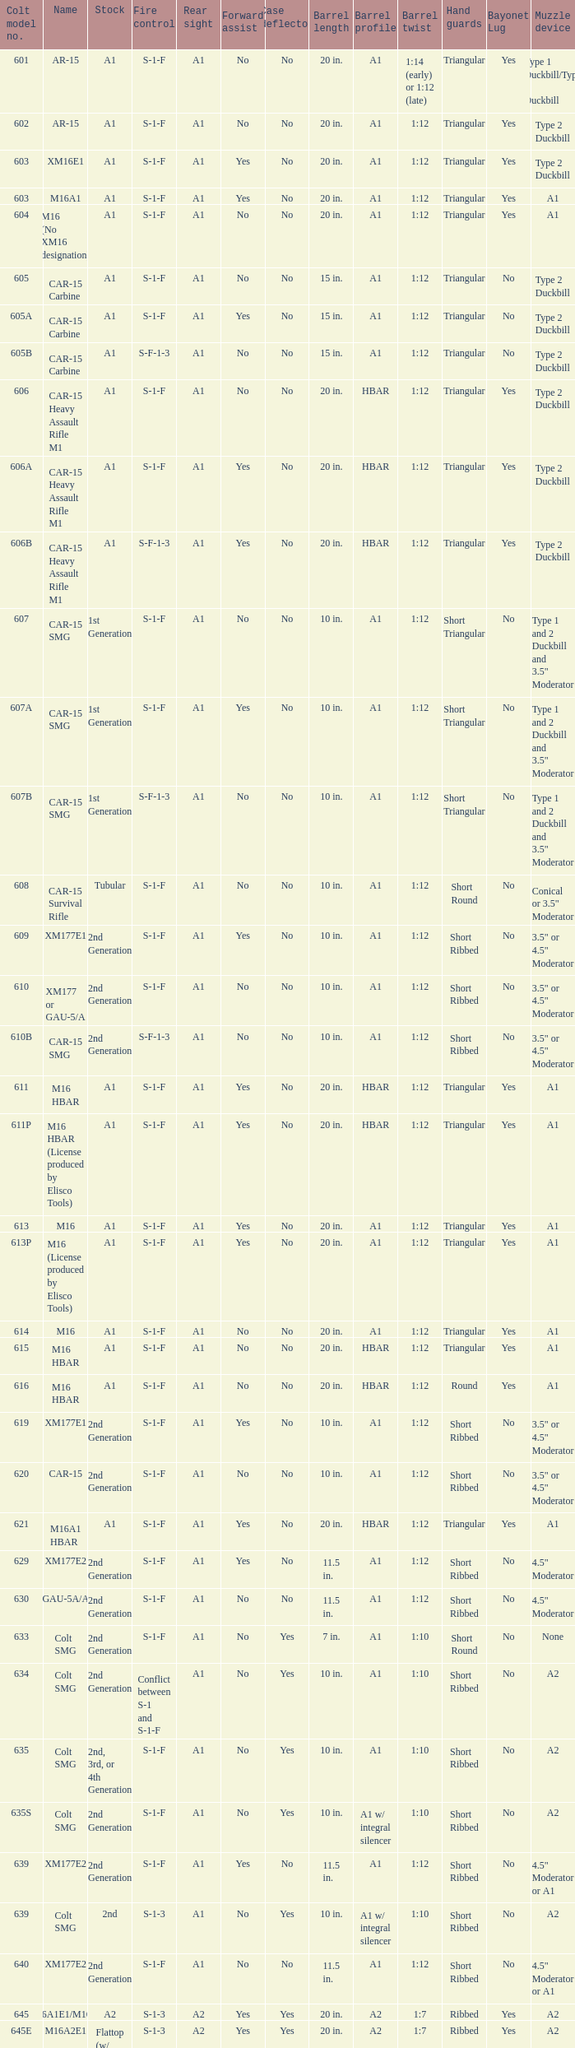Parse the full table. {'header': ['Colt model no.', 'Name', 'Stock', 'Fire control', 'Rear sight', 'Forward assist', 'Case deflector', 'Barrel length', 'Barrel profile', 'Barrel twist', 'Hand guards', 'Bayonet Lug', 'Muzzle device'], 'rows': [['601', 'AR-15', 'A1', 'S-1-F', 'A1', 'No', 'No', '20 in.', 'A1', '1:14 (early) or 1:12 (late)', 'Triangular', 'Yes', 'Type 1 Duckbill/Type 2 Duckbill'], ['602', 'AR-15', 'A1', 'S-1-F', 'A1', 'No', 'No', '20 in.', 'A1', '1:12', 'Triangular', 'Yes', 'Type 2 Duckbill'], ['603', 'XM16E1', 'A1', 'S-1-F', 'A1', 'Yes', 'No', '20 in.', 'A1', '1:12', 'Triangular', 'Yes', 'Type 2 Duckbill'], ['603', 'M16A1', 'A1', 'S-1-F', 'A1', 'Yes', 'No', '20 in.', 'A1', '1:12', 'Triangular', 'Yes', 'A1'], ['604', 'M16 (No XM16 designation)', 'A1', 'S-1-F', 'A1', 'No', 'No', '20 in.', 'A1', '1:12', 'Triangular', 'Yes', 'A1'], ['605', 'CAR-15 Carbine', 'A1', 'S-1-F', 'A1', 'No', 'No', '15 in.', 'A1', '1:12', 'Triangular', 'No', 'Type 2 Duckbill'], ['605A', 'CAR-15 Carbine', 'A1', 'S-1-F', 'A1', 'Yes', 'No', '15 in.', 'A1', '1:12', 'Triangular', 'No', 'Type 2 Duckbill'], ['605B', 'CAR-15 Carbine', 'A1', 'S-F-1-3', 'A1', 'No', 'No', '15 in.', 'A1', '1:12', 'Triangular', 'No', 'Type 2 Duckbill'], ['606', 'CAR-15 Heavy Assault Rifle M1', 'A1', 'S-1-F', 'A1', 'No', 'No', '20 in.', 'HBAR', '1:12', 'Triangular', 'Yes', 'Type 2 Duckbill'], ['606A', 'CAR-15 Heavy Assault Rifle M1', 'A1', 'S-1-F', 'A1', 'Yes', 'No', '20 in.', 'HBAR', '1:12', 'Triangular', 'Yes', 'Type 2 Duckbill'], ['606B', 'CAR-15 Heavy Assault Rifle M1', 'A1', 'S-F-1-3', 'A1', 'Yes', 'No', '20 in.', 'HBAR', '1:12', 'Triangular', 'Yes', 'Type 2 Duckbill'], ['607', 'CAR-15 SMG', '1st Generation', 'S-1-F', 'A1', 'No', 'No', '10 in.', 'A1', '1:12', 'Short Triangular', 'No', 'Type 1 and 2 Duckbill and 3.5" Moderator'], ['607A', 'CAR-15 SMG', '1st Generation', 'S-1-F', 'A1', 'Yes', 'No', '10 in.', 'A1', '1:12', 'Short Triangular', 'No', 'Type 1 and 2 Duckbill and 3.5" Moderator'], ['607B', 'CAR-15 SMG', '1st Generation', 'S-F-1-3', 'A1', 'No', 'No', '10 in.', 'A1', '1:12', 'Short Triangular', 'No', 'Type 1 and 2 Duckbill and 3.5" Moderator'], ['608', 'CAR-15 Survival Rifle', 'Tubular', 'S-1-F', 'A1', 'No', 'No', '10 in.', 'A1', '1:12', 'Short Round', 'No', 'Conical or 3.5" Moderator'], ['609', 'XM177E1', '2nd Generation', 'S-1-F', 'A1', 'Yes', 'No', '10 in.', 'A1', '1:12', 'Short Ribbed', 'No', '3.5" or 4.5" Moderator'], ['610', 'XM177 or GAU-5/A', '2nd Generation', 'S-1-F', 'A1', 'No', 'No', '10 in.', 'A1', '1:12', 'Short Ribbed', 'No', '3.5" or 4.5" Moderator'], ['610B', 'CAR-15 SMG', '2nd Generation', 'S-F-1-3', 'A1', 'No', 'No', '10 in.', 'A1', '1:12', 'Short Ribbed', 'No', '3.5" or 4.5" Moderator'], ['611', 'M16 HBAR', 'A1', 'S-1-F', 'A1', 'Yes', 'No', '20 in.', 'HBAR', '1:12', 'Triangular', 'Yes', 'A1'], ['611P', 'M16 HBAR (License produced by Elisco Tools)', 'A1', 'S-1-F', 'A1', 'Yes', 'No', '20 in.', 'HBAR', '1:12', 'Triangular', 'Yes', 'A1'], ['613', 'M16', 'A1', 'S-1-F', 'A1', 'Yes', 'No', '20 in.', 'A1', '1:12', 'Triangular', 'Yes', 'A1'], ['613P', 'M16 (License produced by Elisco Tools)', 'A1', 'S-1-F', 'A1', 'Yes', 'No', '20 in.', 'A1', '1:12', 'Triangular', 'Yes', 'A1'], ['614', 'M16', 'A1', 'S-1-F', 'A1', 'No', 'No', '20 in.', 'A1', '1:12', 'Triangular', 'Yes', 'A1'], ['615', 'M16 HBAR', 'A1', 'S-1-F', 'A1', 'No', 'No', '20 in.', 'HBAR', '1:12', 'Triangular', 'Yes', 'A1'], ['616', 'M16 HBAR', 'A1', 'S-1-F', 'A1', 'No', 'No', '20 in.', 'HBAR', '1:12', 'Round', 'Yes', 'A1'], ['619', 'XM177E1', '2nd Generation', 'S-1-F', 'A1', 'Yes', 'No', '10 in.', 'A1', '1:12', 'Short Ribbed', 'No', '3.5" or 4.5" Moderator'], ['620', 'CAR-15', '2nd Generation', 'S-1-F', 'A1', 'No', 'No', '10 in.', 'A1', '1:12', 'Short Ribbed', 'No', '3.5" or 4.5" Moderator'], ['621', 'M16A1 HBAR', 'A1', 'S-1-F', 'A1', 'Yes', 'No', '20 in.', 'HBAR', '1:12', 'Triangular', 'Yes', 'A1'], ['629', 'XM177E2', '2nd Generation', 'S-1-F', 'A1', 'Yes', 'No', '11.5 in.', 'A1', '1:12', 'Short Ribbed', 'No', '4.5" Moderator'], ['630', 'GAU-5A/A', '2nd Generation', 'S-1-F', 'A1', 'No', 'No', '11.5 in.', 'A1', '1:12', 'Short Ribbed', 'No', '4.5" Moderator'], ['633', 'Colt SMG', '2nd Generation', 'S-1-F', 'A1', 'No', 'Yes', '7 in.', 'A1', '1:10', 'Short Round', 'No', 'None'], ['634', 'Colt SMG', '2nd Generation', 'Conflict between S-1 and S-1-F', 'A1', 'No', 'Yes', '10 in.', 'A1', '1:10', 'Short Ribbed', 'No', 'A2'], ['635', 'Colt SMG', '2nd, 3rd, or 4th Generation', 'S-1-F', 'A1', 'No', 'Yes', '10 in.', 'A1', '1:10', 'Short Ribbed', 'No', 'A2'], ['635S', 'Colt SMG', '2nd Generation', 'S-1-F', 'A1', 'No', 'Yes', '10 in.', 'A1 w/ integral silencer', '1:10', 'Short Ribbed', 'No', 'A2'], ['639', 'XM177E2', '2nd Generation', 'S-1-F', 'A1', 'Yes', 'No', '11.5 in.', 'A1', '1:12', 'Short Ribbed', 'No', '4.5" Moderator or A1'], ['639', 'Colt SMG', '2nd', 'S-1-3', 'A1', 'No', 'Yes', '10 in.', 'A1 w/ integral silencer', '1:10', 'Short Ribbed', 'No', 'A2'], ['640', 'XM177E2', '2nd Generation', 'S-1-F', 'A1', 'No', 'No', '11.5 in.', 'A1', '1:12', 'Short Ribbed', 'No', '4.5" Moderator or A1'], ['645', 'M16A1E1/M16A2', 'A2', 'S-1-3', 'A2', 'Yes', 'Yes', '20 in.', 'A2', '1:7', 'Ribbed', 'Yes', 'A2'], ['645E', 'M16A2E1', 'Flattop (w/ flip down front sight)', 'S-1-3', 'A2', 'Yes', 'Yes', '20 in.', 'A2', '1:7', 'Ribbed', 'Yes', 'A2'], ['646', 'M16A2E3/M16A3', 'A2', 'S-1-F', 'A2', 'Yes', 'Yes', '20 in.', 'A2', '1:7', 'Ribbed', 'Yes', 'A2'], ['649', 'GAU-5A/A', '2nd Generation', 'S-1-F', 'A1', 'No', 'No', '11.5 in.', 'A1', '1:12', 'Short Ribbed', 'No', '4.5" Moderator'], ['650', 'M16A1 carbine', 'A1', 'S-1-F', 'A1', 'Yes', 'No', '14.5 in.', 'A1', '1:12', 'Short Ribbed', 'Yes', 'A1'], ['651', 'M16A1 carbine', 'A1', 'S-1-F', 'A1', 'Yes', 'No', '14.5 in.', 'A1', '1:12', 'Short Ribbed', 'Yes', 'A1'], ['652', 'M16A1 carbine', 'A1', 'S-1-F', 'A1', 'No', 'No', '14.5 in.', 'A1', '1:12', 'Short Ribbed', 'Yes', 'A1'], ['653', 'M16A1 carbine', '2nd Generation', 'S-1-F', 'A1', 'Yes', 'No', '14.5 in.', 'A1', '1:12', 'Short Ribbed', 'Yes', 'A1'], ['653P', 'M16A1 carbine (License produced by Elisco Tools)', '2nd Generation', 'S-1-F', 'A1', 'Yes', 'No', '14.5 in.', 'A1', '1:12', 'Short Ribbed', 'Yes', 'A1'], ['654', 'M16A1 carbine', '2nd Generation', 'S-1-F', 'A1', 'No', 'No', '14.5 in.', 'A1', '1:12', 'Short Ribbed', 'Yes', 'A1'], ['656', 'M16A1 Special Low Profile', 'A1', 'S-1-F', 'Flattop', 'Yes', 'No', '20 in.', 'HBAR', '1:12', 'Triangular', 'Yes', 'A1'], ['701', 'M16A2', 'A2', 'S-1-F', 'A2', 'Yes', 'Yes', '20 in.', 'A2', '1:7', 'Ribbed', 'Yes', 'A2'], ['702', 'M16A2', 'A2', 'S-1-3', 'A2', 'Yes', 'Yes', '20 in.', 'A2', '1:7', 'Ribbed', 'Yes', 'A2'], ['703', 'M16A2', 'A2', 'S-1-F', 'A2', 'Yes', 'Yes', '20 in.', 'A1', '1:7', 'Ribbed', 'Yes', 'A2'], ['705', 'M16A2', 'A2', 'S-1-3', 'A2', 'Yes', 'Yes', '20 in.', 'A2', '1:7', 'Ribbed', 'Yes', 'A2'], ['707', 'M16A2', 'A2', 'S-1-3', 'A2', 'Yes', 'Yes', '20 in.', 'A1', '1:7', 'Ribbed', 'Yes', 'A2'], ['711', 'M16A2', 'A2', 'S-1-F', 'A1', 'Yes', 'No and Yes', '20 in.', 'A1', '1:7', 'Ribbed', 'Yes', 'A2'], ['713', 'M16A2', 'A2', 'S-1-3', 'A2', 'Yes', 'Yes', '20 in.', 'A2', '1:7', 'Ribbed', 'Yes', 'A2'], ['719', 'M16A2', 'A2', 'S-1-3', 'A2', 'Yes', 'Yes', '20 in.', 'A1', '1:7', 'Ribbed', 'Yes', 'A2'], ['720', 'XM4 Carbine', '3rd Generation', 'S-1-3', 'A2', 'Yes', 'Yes', '14.5 in.', 'M4', '1:7', 'Short Ribbed', 'Yes', 'A2'], ['723', 'M16A2 carbine', '3rd Generation', 'S-1-F', 'A1', 'Yes', 'Yes', '14.5 in.', 'A1', '1:7', 'Short Ribbed', 'Yes', 'A1'], ['725A', 'M16A2 carbine', '3rd Generation', 'S-1-F', 'A1', 'Yes', 'Yes', '14.5 in.', 'A1', '1:7', 'Short Ribbed', 'Yes', 'A2'], ['725B', 'M16A2 carbine', '3rd Generation', 'S-1-F', 'A1', 'Yes', 'Yes', '14.5 in.', 'A2', '1:7', 'Short Ribbed', 'Yes', 'A2'], ['726', 'M16A2 carbine', '3rd Generation', 'S-1-F', 'A1', 'Yes', 'Yes', '14.5 in.', 'A1', '1:7', 'Short Ribbed', 'Yes', 'A1'], ['727', 'M16A2 carbine', '3rd Generation', 'S-1-F', 'A2', 'Yes', 'Yes', '14.5 in.', 'M4', '1:7', 'Short Ribbed', 'Yes', 'A2'], ['728', 'M16A2 carbine', '3rd Generation', 'S-1-F', 'A2', 'Yes', 'Yes', '14.5 in.', 'M4', '1:7', 'Short Ribbed', 'Yes', 'A2'], ['733', 'M16A2 Commando / M4 Commando', '3rd or 4th Generation', 'S-1-F', 'A1 or A2', 'Yes', 'Yes or No', '11.5 in.', 'A1 or A2', '1:7', 'Short Ribbed', 'No', 'A1 or A2'], ['733A', 'M16A2 Commando / M4 Commando', '3rd or 4th Generation', 'S-1-3', 'A1 or A2', 'Yes', 'Yes or No', '11.5 in.', 'A1 or A2', '1:7', 'Short Ribbed', 'No', 'A1 or A2'], ['734', 'M16A2 Commando', '3rd Generation', 'S-1-F', 'A1 or A2', 'Yes', 'Yes or No', '11.5 in.', 'A1 or A2', '1:7', 'Short Ribbed', 'No', 'A1 or A2'], ['734A', 'M16A2 Commando', '3rd Generation', 'S-1-3', 'A1 or A2', 'Yes', 'Yes or No', '11.5 in.', 'A1 or A2', '1:7', 'Short Ribbed', 'No', 'A1 or A2'], ['735', 'M16A2 Commando / M4 Commando', '3rd or 4th Generation', 'S-1-3', 'A1 or A2', 'Yes', 'Yes or No', '11.5 in.', 'A1 or A2', '1:7', 'Short Ribbed', 'No', 'A1 or A2'], ['737', 'M16A2', 'A2', 'S-1-3', 'A2', 'Yes', 'Yes', '20 in.', 'HBAR', '1:7', 'Ribbed', 'Yes', 'A2'], ['738', 'M4 Commando Enhanced', '4th Generation', 'S-1-3-F', 'A2', 'Yes', 'Yes', '11.5 in.', 'A2', '1:7', 'Short Ribbed', 'No', 'A1 or A2'], ['741', 'M16A2', 'A2', 'S-1-F', 'A2', 'Yes', 'Yes', '20 in.', 'HBAR', '1:7', 'Ribbed', 'Yes', 'A2'], ['742', 'M16A2 (Standard w/ bipod)', 'A2', 'S-1-F', 'A2', 'Yes', 'Yes', '20 in.', 'HBAR', '1:7', 'Ribbed', 'Yes', 'A2'], ['745', 'M16A2 (Standard w/ bipod)', 'A2', 'S-1-3', 'A2', 'Yes', 'Yes', '20 in.', 'HBAR', '1:7', 'Ribbed', 'Yes', 'A2'], ['746', 'M16A2 (Standard w/ bipod)', 'A2', 'S-1-3', 'A2', 'Yes', 'Yes', '20 in.', 'HBAR', '1:7', 'Ribbed', 'Yes', 'A2'], ['750', 'LMG (Colt/ Diemaco project)', 'A2', 'S-F', 'A2', 'Yes', 'Yes', '20 in.', 'HBAR', '1:7', 'Square LMG', 'Yes', 'A2'], ['777', 'M4 Carbine', '4th Generation', 'S-1-3', 'A2', 'Yes', 'Yes', '14.5 in.', 'M4', '1:7', 'M4', 'Yes', 'A2'], ['778', 'M4 Carbine Enhanced', '4th Generation', 'S-1-3-F', 'A2', 'Yes', 'Yes', '14.5 in.', 'M4', '1:7', 'M4', 'Yes', 'A2'], ['779', 'M4 Carbine', '4th Generation', 'S-1-F', 'A2', 'Yes', 'Yes', '14.5 in.', 'M4', '1:7', 'M4', 'Yes', 'A2'], ['901', 'M16A3', 'A2', 'S-1-F', 'Flattop', 'Yes', 'Yes', '20 in.', 'A2', '1:7', 'Ribbed', 'Yes', 'A2'], ['905', 'M16A4', 'A2', 'S-1-3', 'Flattop', 'Yes', 'Yes', '20 in.', 'A2', '1:7', 'Ribbed', 'Yes', 'A2'], ['920', 'M4 Carbine', '3rd and 4th Generation', 'S-1-3', 'Flattop', 'Yes', 'Yes', '14.5 in.', 'M4', '1:7', 'M4', 'Yes', 'A2'], ['921', 'M4E1/A1 Carbine', '4th Generation', 'S-1-F', 'Flattop', 'Yes', 'Yes', '14.5 in.', 'M4', '1:7', 'M4', 'Yes', 'A2'], ['921HB', 'M4A1 Carbine', '4th Generation', 'S-1-F', 'Flattop', 'Yes', 'Yes', '14.5 in.', 'M4 HBAR', '1:7', 'M4', 'Yes', 'A2'], ['925', 'M4E2 Carbine', '3rd or 4th Generation', 'S-1-3', 'Flattop', 'Yes', 'Yes', '14.5 in.', 'M4', '1:7', 'M4', 'Yes', 'A2'], ['927', 'M4 Carbine', '4th Generation', 'S-1-F', 'Flattop', 'Yes', 'Yes', '14.5 in.', 'M4', '1:7', 'M4', 'Yes', 'A2'], ['933', 'M4 Commando', '4th Generation', 'S-1-F', 'Flattop', 'Yes', 'Yes', '11.5 in.', 'A1 or A2', '1:7', 'Short Ribbed', 'No', 'A2'], ['935', 'M4 Commando', '4th Generation', 'S-1-3', 'Flattop', 'Yes', 'Yes', '11.5 in.', 'A1 or A2', '1:7', 'Short Ribbed', 'No', 'A2'], ['938', 'M4 Commando Enhanced', '4th Generation', 'S-1-3-F', 'Flattop', 'Yes', 'Yes', '11.5 in.', 'A2', '1:7', 'M4', 'No', 'A2'], ['977', 'M4 Carbine', '4th Generation', 'S-1-3', 'Flattop', 'Yes', 'Yes', '14.5 in.', 'M4', '1:7', 'M4', 'Yes', 'A2'], ['941', 'M16A3', 'A2', 'S-1-F', 'Flattop', 'Yes', 'Yes', '20 in.', 'HBAR', '1:7', 'Ribbed', 'Yes', 'A2'], ['942', 'M16A3 (Standard w/ bipod)', 'A2', 'S-1-F', 'Flattop', 'Yes', 'Yes', '20 in.', 'HBAR', '1:7', 'Ribbed', 'Yes', 'A2'], ['945', 'M16A2E4/M16A4', 'A2', 'S-1-3', 'Flattop', 'Yes', 'Yes', '20 in.', 'A2', '1:7', 'Ribbed', 'Yes', 'A2'], ['950', 'LMG (Colt/ Diemaco project)', 'A2', 'S-F', 'Flattop', 'Yes', 'Yes', '20 in.', 'HBAR', '1:7', 'Square LMG', 'Yes', 'A2'], ['"977"', 'M4 Carbine', '4th Generation', 'S-1-3', 'Flattop', 'Yes', 'Yes', '14.5 in.', 'M4', '1:7', 'M4', 'Yes', 'A2'], ['978', 'M4 Carbine Enhanced', '4th Generation', 'S-1-3-F', 'Flattop', 'Yes', 'Yes', '14.5 in.', 'M4', '1:7', 'M4', 'Yes', 'A2'], ['979', 'M4A1 Carbine', '4th Generation', 'S-1-F', 'Flattop', 'Yes', 'Yes', '14.5 in.', 'M4', '1:7', 'M4', 'Yes', 'A2']]} What is the back sight in the cole model no. 735? A1 or A2. 